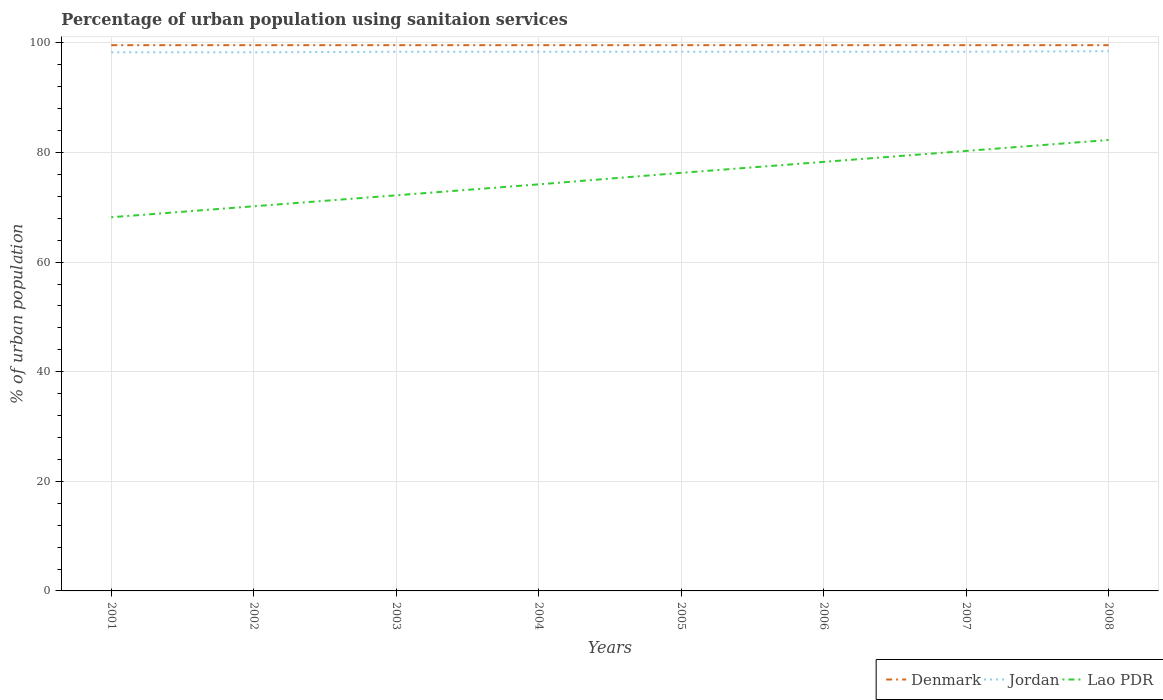How many different coloured lines are there?
Your answer should be compact. 3. Does the line corresponding to Denmark intersect with the line corresponding to Jordan?
Keep it short and to the point. No. Across all years, what is the maximum percentage of urban population using sanitaion services in Lao PDR?
Keep it short and to the point. 68.2. What is the difference between the highest and the second highest percentage of urban population using sanitaion services in Jordan?
Ensure brevity in your answer.  0.2. Is the percentage of urban population using sanitaion services in Lao PDR strictly greater than the percentage of urban population using sanitaion services in Denmark over the years?
Offer a terse response. Yes. How many lines are there?
Your answer should be compact. 3. Are the values on the major ticks of Y-axis written in scientific E-notation?
Make the answer very short. No. Does the graph contain grids?
Provide a short and direct response. Yes. Where does the legend appear in the graph?
Provide a short and direct response. Bottom right. How many legend labels are there?
Keep it short and to the point. 3. What is the title of the graph?
Offer a very short reply. Percentage of urban population using sanitaion services. What is the label or title of the Y-axis?
Your answer should be very brief. % of urban population. What is the % of urban population in Denmark in 2001?
Offer a very short reply. 99.6. What is the % of urban population of Jordan in 2001?
Give a very brief answer. 98.3. What is the % of urban population of Lao PDR in 2001?
Offer a very short reply. 68.2. What is the % of urban population of Denmark in 2002?
Keep it short and to the point. 99.6. What is the % of urban population of Jordan in 2002?
Make the answer very short. 98.3. What is the % of urban population of Lao PDR in 2002?
Provide a succinct answer. 70.2. What is the % of urban population in Denmark in 2003?
Offer a very short reply. 99.6. What is the % of urban population in Jordan in 2003?
Your answer should be very brief. 98.4. What is the % of urban population in Lao PDR in 2003?
Offer a very short reply. 72.2. What is the % of urban population of Denmark in 2004?
Provide a succinct answer. 99.6. What is the % of urban population of Jordan in 2004?
Keep it short and to the point. 98.4. What is the % of urban population in Lao PDR in 2004?
Provide a succinct answer. 74.2. What is the % of urban population in Denmark in 2005?
Your answer should be compact. 99.6. What is the % of urban population in Jordan in 2005?
Ensure brevity in your answer.  98.4. What is the % of urban population in Lao PDR in 2005?
Your response must be concise. 76.3. What is the % of urban population in Denmark in 2006?
Offer a very short reply. 99.6. What is the % of urban population of Jordan in 2006?
Your answer should be compact. 98.4. What is the % of urban population of Lao PDR in 2006?
Offer a very short reply. 78.3. What is the % of urban population in Denmark in 2007?
Keep it short and to the point. 99.6. What is the % of urban population in Jordan in 2007?
Your response must be concise. 98.4. What is the % of urban population of Lao PDR in 2007?
Your answer should be compact. 80.3. What is the % of urban population in Denmark in 2008?
Give a very brief answer. 99.6. What is the % of urban population in Jordan in 2008?
Your answer should be very brief. 98.5. What is the % of urban population in Lao PDR in 2008?
Provide a succinct answer. 82.3. Across all years, what is the maximum % of urban population of Denmark?
Keep it short and to the point. 99.6. Across all years, what is the maximum % of urban population of Jordan?
Your answer should be compact. 98.5. Across all years, what is the maximum % of urban population of Lao PDR?
Keep it short and to the point. 82.3. Across all years, what is the minimum % of urban population in Denmark?
Your response must be concise. 99.6. Across all years, what is the minimum % of urban population of Jordan?
Ensure brevity in your answer.  98.3. Across all years, what is the minimum % of urban population of Lao PDR?
Provide a succinct answer. 68.2. What is the total % of urban population in Denmark in the graph?
Offer a very short reply. 796.8. What is the total % of urban population in Jordan in the graph?
Your answer should be very brief. 787.1. What is the total % of urban population in Lao PDR in the graph?
Provide a succinct answer. 602. What is the difference between the % of urban population in Denmark in 2001 and that in 2002?
Your answer should be compact. 0. What is the difference between the % of urban population in Denmark in 2001 and that in 2003?
Offer a terse response. 0. What is the difference between the % of urban population of Lao PDR in 2001 and that in 2003?
Provide a short and direct response. -4. What is the difference between the % of urban population in Jordan in 2001 and that in 2004?
Offer a very short reply. -0.1. What is the difference between the % of urban population of Lao PDR in 2001 and that in 2004?
Provide a succinct answer. -6. What is the difference between the % of urban population of Denmark in 2001 and that in 2006?
Offer a very short reply. 0. What is the difference between the % of urban population of Jordan in 2001 and that in 2006?
Offer a terse response. -0.1. What is the difference between the % of urban population of Lao PDR in 2001 and that in 2006?
Provide a short and direct response. -10.1. What is the difference between the % of urban population in Denmark in 2001 and that in 2008?
Your response must be concise. 0. What is the difference between the % of urban population in Lao PDR in 2001 and that in 2008?
Your answer should be very brief. -14.1. What is the difference between the % of urban population in Denmark in 2002 and that in 2003?
Give a very brief answer. 0. What is the difference between the % of urban population in Jordan in 2002 and that in 2003?
Your answer should be compact. -0.1. What is the difference between the % of urban population in Lao PDR in 2002 and that in 2003?
Provide a succinct answer. -2. What is the difference between the % of urban population in Denmark in 2002 and that in 2004?
Ensure brevity in your answer.  0. What is the difference between the % of urban population in Lao PDR in 2002 and that in 2004?
Offer a terse response. -4. What is the difference between the % of urban population of Lao PDR in 2002 and that in 2005?
Your answer should be compact. -6.1. What is the difference between the % of urban population in Denmark in 2002 and that in 2006?
Provide a succinct answer. 0. What is the difference between the % of urban population in Jordan in 2002 and that in 2006?
Give a very brief answer. -0.1. What is the difference between the % of urban population in Jordan in 2002 and that in 2007?
Offer a terse response. -0.1. What is the difference between the % of urban population of Lao PDR in 2002 and that in 2007?
Offer a terse response. -10.1. What is the difference between the % of urban population in Denmark in 2002 and that in 2008?
Your response must be concise. 0. What is the difference between the % of urban population in Lao PDR in 2002 and that in 2008?
Keep it short and to the point. -12.1. What is the difference between the % of urban population of Denmark in 2003 and that in 2004?
Offer a terse response. 0. What is the difference between the % of urban population of Jordan in 2003 and that in 2004?
Your response must be concise. 0. What is the difference between the % of urban population in Denmark in 2003 and that in 2005?
Make the answer very short. 0. What is the difference between the % of urban population in Lao PDR in 2003 and that in 2005?
Provide a succinct answer. -4.1. What is the difference between the % of urban population in Denmark in 2003 and that in 2006?
Offer a terse response. 0. What is the difference between the % of urban population of Lao PDR in 2003 and that in 2006?
Give a very brief answer. -6.1. What is the difference between the % of urban population of Jordan in 2003 and that in 2007?
Provide a succinct answer. 0. What is the difference between the % of urban population of Lao PDR in 2003 and that in 2007?
Make the answer very short. -8.1. What is the difference between the % of urban population of Jordan in 2003 and that in 2008?
Ensure brevity in your answer.  -0.1. What is the difference between the % of urban population of Denmark in 2004 and that in 2006?
Provide a succinct answer. 0. What is the difference between the % of urban population in Denmark in 2004 and that in 2007?
Your answer should be very brief. 0. What is the difference between the % of urban population of Lao PDR in 2004 and that in 2007?
Make the answer very short. -6.1. What is the difference between the % of urban population in Denmark in 2004 and that in 2008?
Make the answer very short. 0. What is the difference between the % of urban population of Jordan in 2004 and that in 2008?
Give a very brief answer. -0.1. What is the difference between the % of urban population in Lao PDR in 2004 and that in 2008?
Provide a succinct answer. -8.1. What is the difference between the % of urban population of Denmark in 2005 and that in 2006?
Make the answer very short. 0. What is the difference between the % of urban population in Denmark in 2005 and that in 2007?
Ensure brevity in your answer.  0. What is the difference between the % of urban population of Lao PDR in 2005 and that in 2007?
Ensure brevity in your answer.  -4. What is the difference between the % of urban population of Lao PDR in 2005 and that in 2008?
Keep it short and to the point. -6. What is the difference between the % of urban population of Denmark in 2006 and that in 2007?
Give a very brief answer. 0. What is the difference between the % of urban population of Jordan in 2006 and that in 2008?
Keep it short and to the point. -0.1. What is the difference between the % of urban population in Denmark in 2007 and that in 2008?
Offer a terse response. 0. What is the difference between the % of urban population of Denmark in 2001 and the % of urban population of Jordan in 2002?
Keep it short and to the point. 1.3. What is the difference between the % of urban population of Denmark in 2001 and the % of urban population of Lao PDR in 2002?
Provide a succinct answer. 29.4. What is the difference between the % of urban population of Jordan in 2001 and the % of urban population of Lao PDR in 2002?
Your answer should be very brief. 28.1. What is the difference between the % of urban population of Denmark in 2001 and the % of urban population of Jordan in 2003?
Ensure brevity in your answer.  1.2. What is the difference between the % of urban population of Denmark in 2001 and the % of urban population of Lao PDR in 2003?
Your answer should be very brief. 27.4. What is the difference between the % of urban population of Jordan in 2001 and the % of urban population of Lao PDR in 2003?
Your answer should be compact. 26.1. What is the difference between the % of urban population in Denmark in 2001 and the % of urban population in Lao PDR in 2004?
Offer a very short reply. 25.4. What is the difference between the % of urban population in Jordan in 2001 and the % of urban population in Lao PDR in 2004?
Your answer should be very brief. 24.1. What is the difference between the % of urban population of Denmark in 2001 and the % of urban population of Jordan in 2005?
Keep it short and to the point. 1.2. What is the difference between the % of urban population of Denmark in 2001 and the % of urban population of Lao PDR in 2005?
Offer a very short reply. 23.3. What is the difference between the % of urban population of Jordan in 2001 and the % of urban population of Lao PDR in 2005?
Offer a very short reply. 22. What is the difference between the % of urban population in Denmark in 2001 and the % of urban population in Lao PDR in 2006?
Give a very brief answer. 21.3. What is the difference between the % of urban population in Denmark in 2001 and the % of urban population in Jordan in 2007?
Ensure brevity in your answer.  1.2. What is the difference between the % of urban population of Denmark in 2001 and the % of urban population of Lao PDR in 2007?
Offer a terse response. 19.3. What is the difference between the % of urban population of Denmark in 2001 and the % of urban population of Jordan in 2008?
Give a very brief answer. 1.1. What is the difference between the % of urban population in Denmark in 2001 and the % of urban population in Lao PDR in 2008?
Provide a short and direct response. 17.3. What is the difference between the % of urban population of Jordan in 2001 and the % of urban population of Lao PDR in 2008?
Provide a short and direct response. 16. What is the difference between the % of urban population in Denmark in 2002 and the % of urban population in Jordan in 2003?
Keep it short and to the point. 1.2. What is the difference between the % of urban population of Denmark in 2002 and the % of urban population of Lao PDR in 2003?
Your answer should be compact. 27.4. What is the difference between the % of urban population of Jordan in 2002 and the % of urban population of Lao PDR in 2003?
Your answer should be very brief. 26.1. What is the difference between the % of urban population of Denmark in 2002 and the % of urban population of Jordan in 2004?
Offer a very short reply. 1.2. What is the difference between the % of urban population of Denmark in 2002 and the % of urban population of Lao PDR in 2004?
Give a very brief answer. 25.4. What is the difference between the % of urban population of Jordan in 2002 and the % of urban population of Lao PDR in 2004?
Your answer should be very brief. 24.1. What is the difference between the % of urban population of Denmark in 2002 and the % of urban population of Lao PDR in 2005?
Your answer should be compact. 23.3. What is the difference between the % of urban population of Denmark in 2002 and the % of urban population of Jordan in 2006?
Your answer should be compact. 1.2. What is the difference between the % of urban population of Denmark in 2002 and the % of urban population of Lao PDR in 2006?
Your response must be concise. 21.3. What is the difference between the % of urban population in Jordan in 2002 and the % of urban population in Lao PDR in 2006?
Your response must be concise. 20. What is the difference between the % of urban population in Denmark in 2002 and the % of urban population in Lao PDR in 2007?
Your answer should be very brief. 19.3. What is the difference between the % of urban population in Jordan in 2002 and the % of urban population in Lao PDR in 2007?
Provide a succinct answer. 18. What is the difference between the % of urban population of Denmark in 2002 and the % of urban population of Lao PDR in 2008?
Your answer should be compact. 17.3. What is the difference between the % of urban population in Denmark in 2003 and the % of urban population in Lao PDR in 2004?
Your answer should be very brief. 25.4. What is the difference between the % of urban population of Jordan in 2003 and the % of urban population of Lao PDR in 2004?
Your response must be concise. 24.2. What is the difference between the % of urban population of Denmark in 2003 and the % of urban population of Lao PDR in 2005?
Offer a very short reply. 23.3. What is the difference between the % of urban population in Jordan in 2003 and the % of urban population in Lao PDR in 2005?
Keep it short and to the point. 22.1. What is the difference between the % of urban population of Denmark in 2003 and the % of urban population of Lao PDR in 2006?
Give a very brief answer. 21.3. What is the difference between the % of urban population in Jordan in 2003 and the % of urban population in Lao PDR in 2006?
Your response must be concise. 20.1. What is the difference between the % of urban population of Denmark in 2003 and the % of urban population of Lao PDR in 2007?
Keep it short and to the point. 19.3. What is the difference between the % of urban population of Jordan in 2003 and the % of urban population of Lao PDR in 2007?
Make the answer very short. 18.1. What is the difference between the % of urban population in Denmark in 2003 and the % of urban population in Lao PDR in 2008?
Keep it short and to the point. 17.3. What is the difference between the % of urban population of Denmark in 2004 and the % of urban population of Jordan in 2005?
Offer a terse response. 1.2. What is the difference between the % of urban population of Denmark in 2004 and the % of urban population of Lao PDR in 2005?
Make the answer very short. 23.3. What is the difference between the % of urban population in Jordan in 2004 and the % of urban population in Lao PDR in 2005?
Offer a very short reply. 22.1. What is the difference between the % of urban population in Denmark in 2004 and the % of urban population in Jordan in 2006?
Give a very brief answer. 1.2. What is the difference between the % of urban population of Denmark in 2004 and the % of urban population of Lao PDR in 2006?
Your answer should be very brief. 21.3. What is the difference between the % of urban population of Jordan in 2004 and the % of urban population of Lao PDR in 2006?
Your answer should be very brief. 20.1. What is the difference between the % of urban population of Denmark in 2004 and the % of urban population of Jordan in 2007?
Make the answer very short. 1.2. What is the difference between the % of urban population in Denmark in 2004 and the % of urban population in Lao PDR in 2007?
Your response must be concise. 19.3. What is the difference between the % of urban population of Jordan in 2004 and the % of urban population of Lao PDR in 2007?
Make the answer very short. 18.1. What is the difference between the % of urban population of Denmark in 2004 and the % of urban population of Jordan in 2008?
Ensure brevity in your answer.  1.1. What is the difference between the % of urban population in Jordan in 2004 and the % of urban population in Lao PDR in 2008?
Provide a succinct answer. 16.1. What is the difference between the % of urban population of Denmark in 2005 and the % of urban population of Jordan in 2006?
Your response must be concise. 1.2. What is the difference between the % of urban population of Denmark in 2005 and the % of urban population of Lao PDR in 2006?
Provide a succinct answer. 21.3. What is the difference between the % of urban population of Jordan in 2005 and the % of urban population of Lao PDR in 2006?
Provide a short and direct response. 20.1. What is the difference between the % of urban population in Denmark in 2005 and the % of urban population in Lao PDR in 2007?
Provide a short and direct response. 19.3. What is the difference between the % of urban population of Jordan in 2005 and the % of urban population of Lao PDR in 2007?
Make the answer very short. 18.1. What is the difference between the % of urban population in Denmark in 2005 and the % of urban population in Jordan in 2008?
Give a very brief answer. 1.1. What is the difference between the % of urban population in Denmark in 2006 and the % of urban population in Jordan in 2007?
Your response must be concise. 1.2. What is the difference between the % of urban population of Denmark in 2006 and the % of urban population of Lao PDR in 2007?
Keep it short and to the point. 19.3. What is the difference between the % of urban population of Denmark in 2006 and the % of urban population of Jordan in 2008?
Your response must be concise. 1.1. What is the difference between the % of urban population in Denmark in 2007 and the % of urban population in Lao PDR in 2008?
Keep it short and to the point. 17.3. What is the difference between the % of urban population of Jordan in 2007 and the % of urban population of Lao PDR in 2008?
Offer a very short reply. 16.1. What is the average % of urban population in Denmark per year?
Ensure brevity in your answer.  99.6. What is the average % of urban population in Jordan per year?
Offer a terse response. 98.39. What is the average % of urban population in Lao PDR per year?
Offer a very short reply. 75.25. In the year 2001, what is the difference between the % of urban population of Denmark and % of urban population of Jordan?
Your answer should be very brief. 1.3. In the year 2001, what is the difference between the % of urban population of Denmark and % of urban population of Lao PDR?
Your answer should be very brief. 31.4. In the year 2001, what is the difference between the % of urban population of Jordan and % of urban population of Lao PDR?
Your answer should be compact. 30.1. In the year 2002, what is the difference between the % of urban population of Denmark and % of urban population of Lao PDR?
Provide a short and direct response. 29.4. In the year 2002, what is the difference between the % of urban population in Jordan and % of urban population in Lao PDR?
Provide a succinct answer. 28.1. In the year 2003, what is the difference between the % of urban population of Denmark and % of urban population of Lao PDR?
Ensure brevity in your answer.  27.4. In the year 2003, what is the difference between the % of urban population in Jordan and % of urban population in Lao PDR?
Your answer should be very brief. 26.2. In the year 2004, what is the difference between the % of urban population in Denmark and % of urban population in Jordan?
Provide a succinct answer. 1.2. In the year 2004, what is the difference between the % of urban population of Denmark and % of urban population of Lao PDR?
Offer a very short reply. 25.4. In the year 2004, what is the difference between the % of urban population in Jordan and % of urban population in Lao PDR?
Keep it short and to the point. 24.2. In the year 2005, what is the difference between the % of urban population in Denmark and % of urban population in Jordan?
Your response must be concise. 1.2. In the year 2005, what is the difference between the % of urban population in Denmark and % of urban population in Lao PDR?
Provide a short and direct response. 23.3. In the year 2005, what is the difference between the % of urban population in Jordan and % of urban population in Lao PDR?
Give a very brief answer. 22.1. In the year 2006, what is the difference between the % of urban population in Denmark and % of urban population in Lao PDR?
Your answer should be very brief. 21.3. In the year 2006, what is the difference between the % of urban population in Jordan and % of urban population in Lao PDR?
Offer a terse response. 20.1. In the year 2007, what is the difference between the % of urban population in Denmark and % of urban population in Jordan?
Provide a succinct answer. 1.2. In the year 2007, what is the difference between the % of urban population of Denmark and % of urban population of Lao PDR?
Keep it short and to the point. 19.3. In the year 2007, what is the difference between the % of urban population of Jordan and % of urban population of Lao PDR?
Provide a short and direct response. 18.1. What is the ratio of the % of urban population of Denmark in 2001 to that in 2002?
Provide a short and direct response. 1. What is the ratio of the % of urban population of Lao PDR in 2001 to that in 2002?
Offer a very short reply. 0.97. What is the ratio of the % of urban population of Denmark in 2001 to that in 2003?
Provide a succinct answer. 1. What is the ratio of the % of urban population in Lao PDR in 2001 to that in 2003?
Make the answer very short. 0.94. What is the ratio of the % of urban population in Lao PDR in 2001 to that in 2004?
Give a very brief answer. 0.92. What is the ratio of the % of urban population of Denmark in 2001 to that in 2005?
Make the answer very short. 1. What is the ratio of the % of urban population in Jordan in 2001 to that in 2005?
Give a very brief answer. 1. What is the ratio of the % of urban population of Lao PDR in 2001 to that in 2005?
Provide a short and direct response. 0.89. What is the ratio of the % of urban population of Jordan in 2001 to that in 2006?
Your answer should be compact. 1. What is the ratio of the % of urban population in Lao PDR in 2001 to that in 2006?
Keep it short and to the point. 0.87. What is the ratio of the % of urban population in Lao PDR in 2001 to that in 2007?
Ensure brevity in your answer.  0.85. What is the ratio of the % of urban population in Denmark in 2001 to that in 2008?
Provide a short and direct response. 1. What is the ratio of the % of urban population of Jordan in 2001 to that in 2008?
Make the answer very short. 1. What is the ratio of the % of urban population of Lao PDR in 2001 to that in 2008?
Make the answer very short. 0.83. What is the ratio of the % of urban population in Jordan in 2002 to that in 2003?
Ensure brevity in your answer.  1. What is the ratio of the % of urban population of Lao PDR in 2002 to that in 2003?
Your answer should be compact. 0.97. What is the ratio of the % of urban population of Lao PDR in 2002 to that in 2004?
Keep it short and to the point. 0.95. What is the ratio of the % of urban population of Lao PDR in 2002 to that in 2005?
Your response must be concise. 0.92. What is the ratio of the % of urban population of Denmark in 2002 to that in 2006?
Your answer should be compact. 1. What is the ratio of the % of urban population of Jordan in 2002 to that in 2006?
Provide a succinct answer. 1. What is the ratio of the % of urban population of Lao PDR in 2002 to that in 2006?
Give a very brief answer. 0.9. What is the ratio of the % of urban population of Denmark in 2002 to that in 2007?
Your answer should be very brief. 1. What is the ratio of the % of urban population in Jordan in 2002 to that in 2007?
Make the answer very short. 1. What is the ratio of the % of urban population in Lao PDR in 2002 to that in 2007?
Provide a short and direct response. 0.87. What is the ratio of the % of urban population in Denmark in 2002 to that in 2008?
Ensure brevity in your answer.  1. What is the ratio of the % of urban population in Jordan in 2002 to that in 2008?
Keep it short and to the point. 1. What is the ratio of the % of urban population in Lao PDR in 2002 to that in 2008?
Ensure brevity in your answer.  0.85. What is the ratio of the % of urban population of Denmark in 2003 to that in 2004?
Provide a succinct answer. 1. What is the ratio of the % of urban population in Jordan in 2003 to that in 2004?
Offer a terse response. 1. What is the ratio of the % of urban population of Denmark in 2003 to that in 2005?
Give a very brief answer. 1. What is the ratio of the % of urban population of Jordan in 2003 to that in 2005?
Keep it short and to the point. 1. What is the ratio of the % of urban population of Lao PDR in 2003 to that in 2005?
Ensure brevity in your answer.  0.95. What is the ratio of the % of urban population of Denmark in 2003 to that in 2006?
Your answer should be compact. 1. What is the ratio of the % of urban population in Lao PDR in 2003 to that in 2006?
Your answer should be very brief. 0.92. What is the ratio of the % of urban population of Lao PDR in 2003 to that in 2007?
Offer a very short reply. 0.9. What is the ratio of the % of urban population in Jordan in 2003 to that in 2008?
Provide a short and direct response. 1. What is the ratio of the % of urban population of Lao PDR in 2003 to that in 2008?
Keep it short and to the point. 0.88. What is the ratio of the % of urban population of Lao PDR in 2004 to that in 2005?
Offer a very short reply. 0.97. What is the ratio of the % of urban population in Jordan in 2004 to that in 2006?
Keep it short and to the point. 1. What is the ratio of the % of urban population in Lao PDR in 2004 to that in 2006?
Provide a short and direct response. 0.95. What is the ratio of the % of urban population in Lao PDR in 2004 to that in 2007?
Provide a short and direct response. 0.92. What is the ratio of the % of urban population in Denmark in 2004 to that in 2008?
Give a very brief answer. 1. What is the ratio of the % of urban population of Jordan in 2004 to that in 2008?
Your answer should be compact. 1. What is the ratio of the % of urban population of Lao PDR in 2004 to that in 2008?
Ensure brevity in your answer.  0.9. What is the ratio of the % of urban population of Denmark in 2005 to that in 2006?
Your response must be concise. 1. What is the ratio of the % of urban population of Jordan in 2005 to that in 2006?
Offer a terse response. 1. What is the ratio of the % of urban population of Lao PDR in 2005 to that in 2006?
Offer a terse response. 0.97. What is the ratio of the % of urban population in Jordan in 2005 to that in 2007?
Your answer should be very brief. 1. What is the ratio of the % of urban population in Lao PDR in 2005 to that in 2007?
Offer a terse response. 0.95. What is the ratio of the % of urban population in Jordan in 2005 to that in 2008?
Offer a terse response. 1. What is the ratio of the % of urban population in Lao PDR in 2005 to that in 2008?
Your response must be concise. 0.93. What is the ratio of the % of urban population in Denmark in 2006 to that in 2007?
Keep it short and to the point. 1. What is the ratio of the % of urban population of Lao PDR in 2006 to that in 2007?
Make the answer very short. 0.98. What is the ratio of the % of urban population of Denmark in 2006 to that in 2008?
Keep it short and to the point. 1. What is the ratio of the % of urban population of Lao PDR in 2006 to that in 2008?
Offer a terse response. 0.95. What is the ratio of the % of urban population of Denmark in 2007 to that in 2008?
Offer a very short reply. 1. What is the ratio of the % of urban population in Jordan in 2007 to that in 2008?
Provide a short and direct response. 1. What is the ratio of the % of urban population of Lao PDR in 2007 to that in 2008?
Offer a terse response. 0.98. What is the difference between the highest and the second highest % of urban population of Denmark?
Offer a very short reply. 0. What is the difference between the highest and the second highest % of urban population of Jordan?
Provide a succinct answer. 0.1. What is the difference between the highest and the lowest % of urban population of Denmark?
Keep it short and to the point. 0. What is the difference between the highest and the lowest % of urban population in Lao PDR?
Your response must be concise. 14.1. 